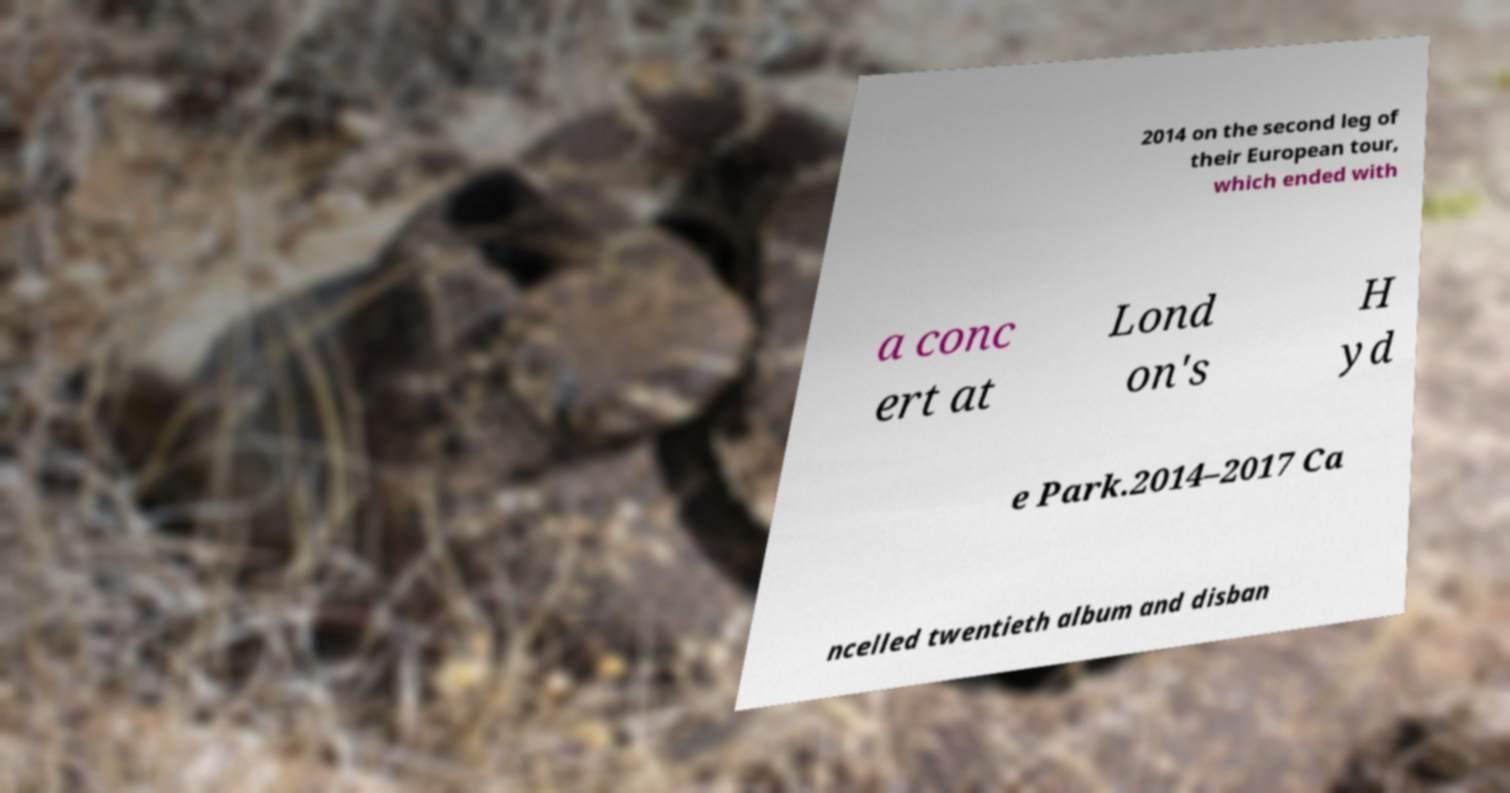For documentation purposes, I need the text within this image transcribed. Could you provide that? 2014 on the second leg of their European tour, which ended with a conc ert at Lond on's H yd e Park.2014–2017 Ca ncelled twentieth album and disban 